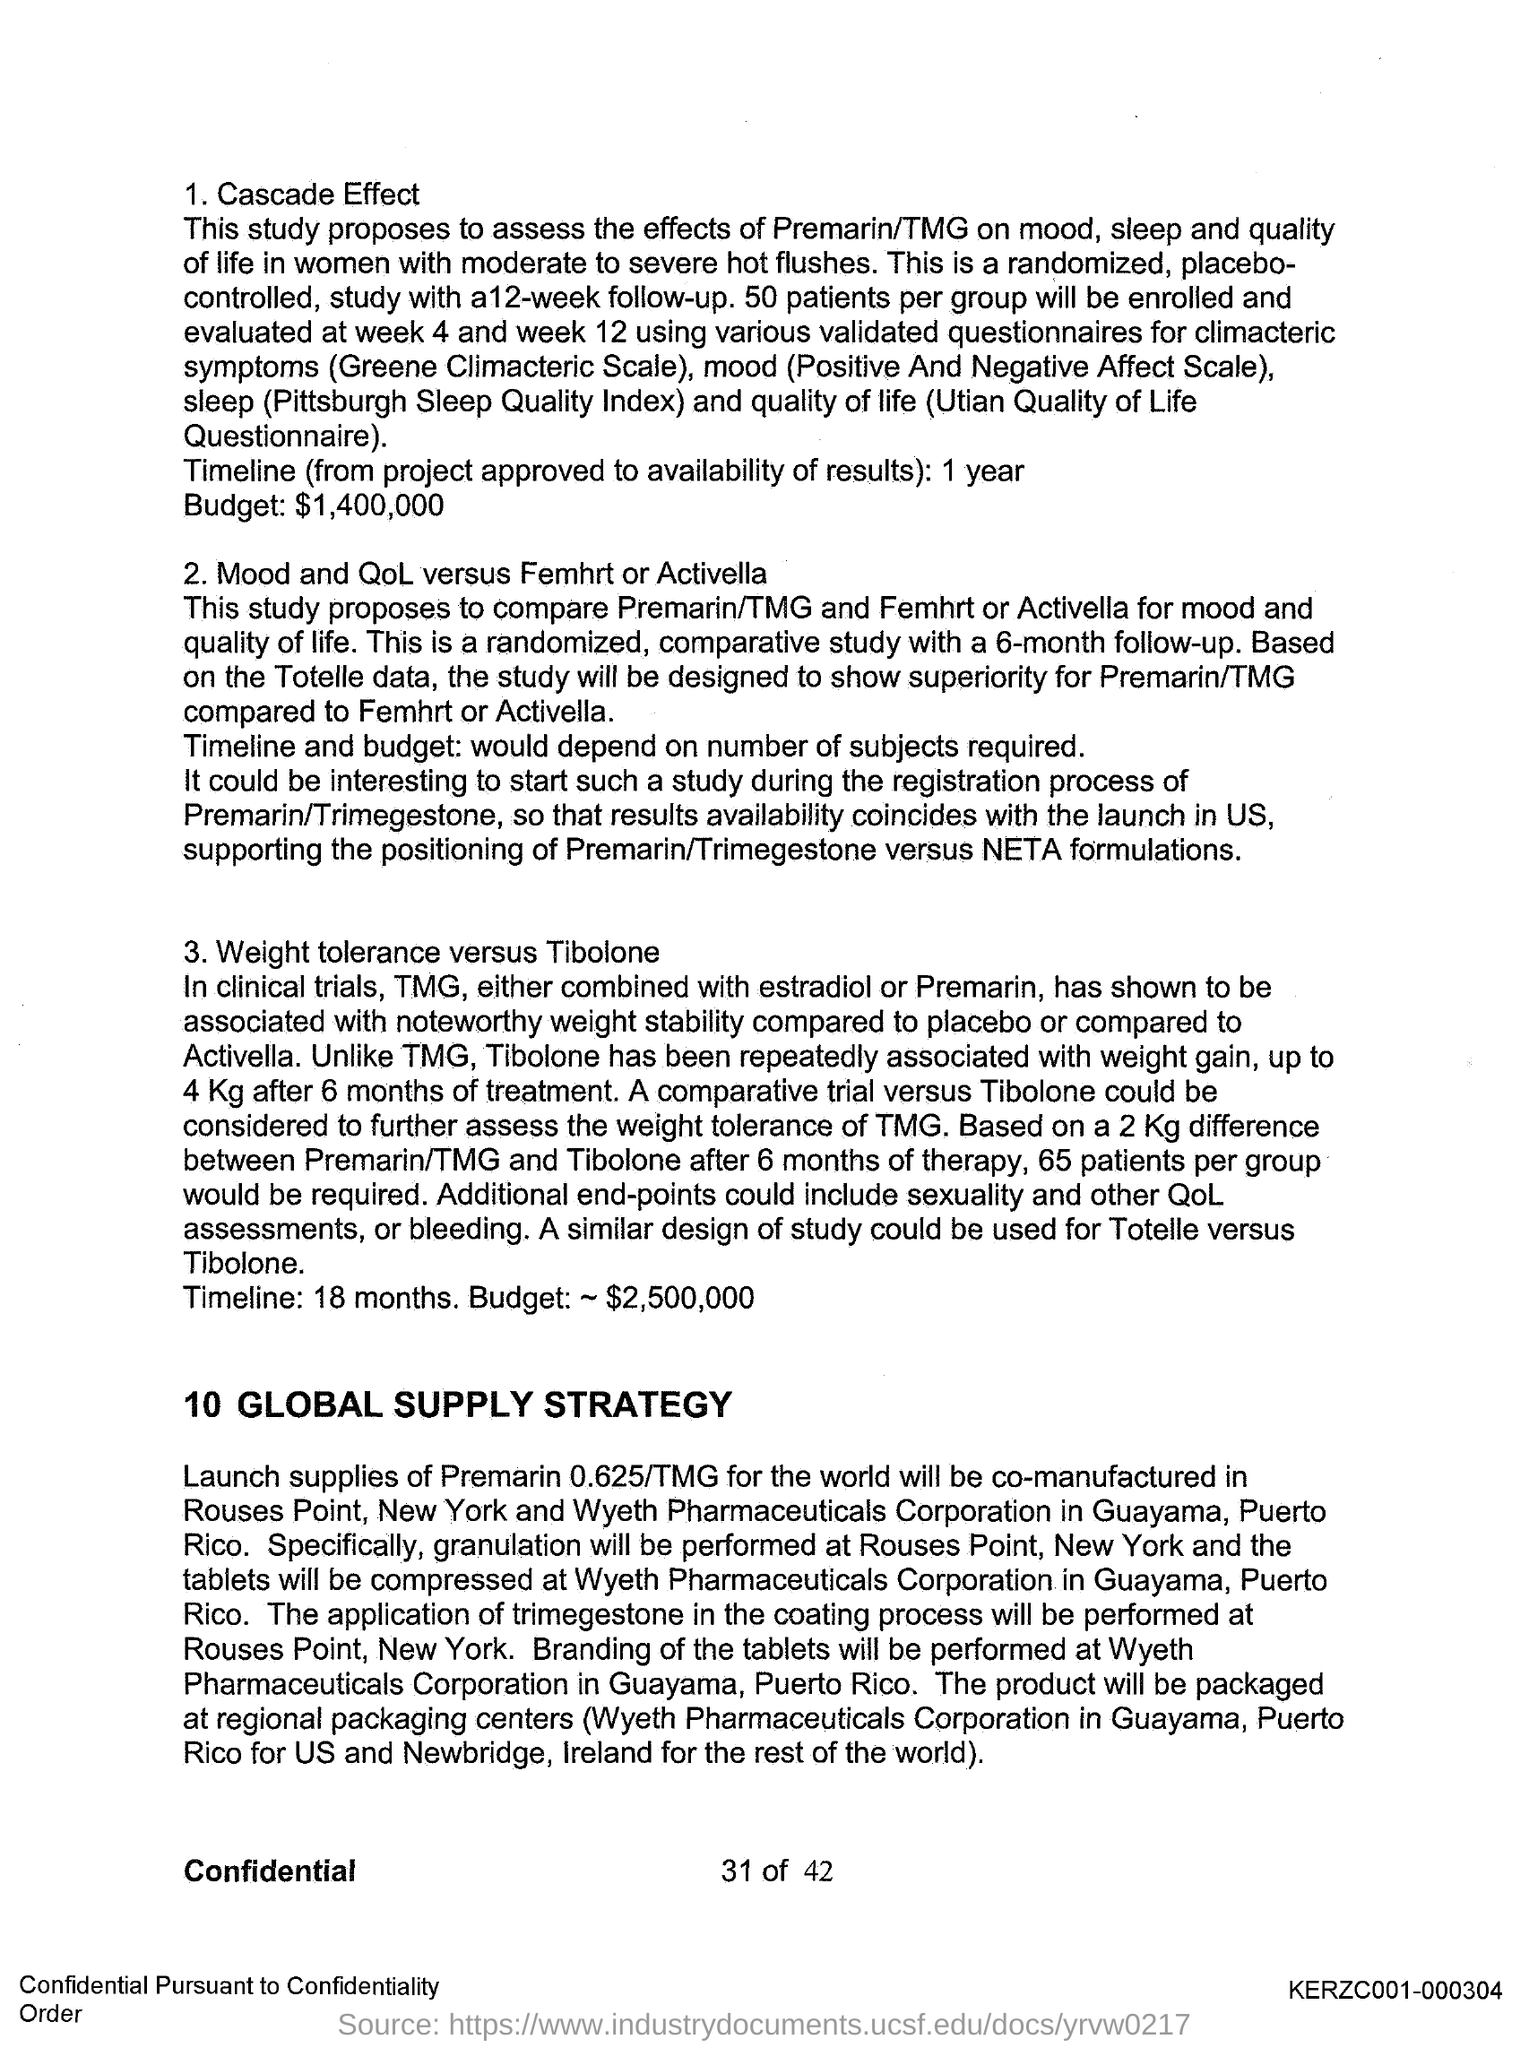What is the timeline of the cascade effect?
Keep it short and to the point. 1 year. What is the budget of the cascade effect?
Give a very brief answer. $1,400,000. What is the timeline of weight tolerance versus tibolone?
Your answer should be very brief. 18 months. What is the budget of weight tolerance versus tibolone?
Your response must be concise. $2,500,000. 